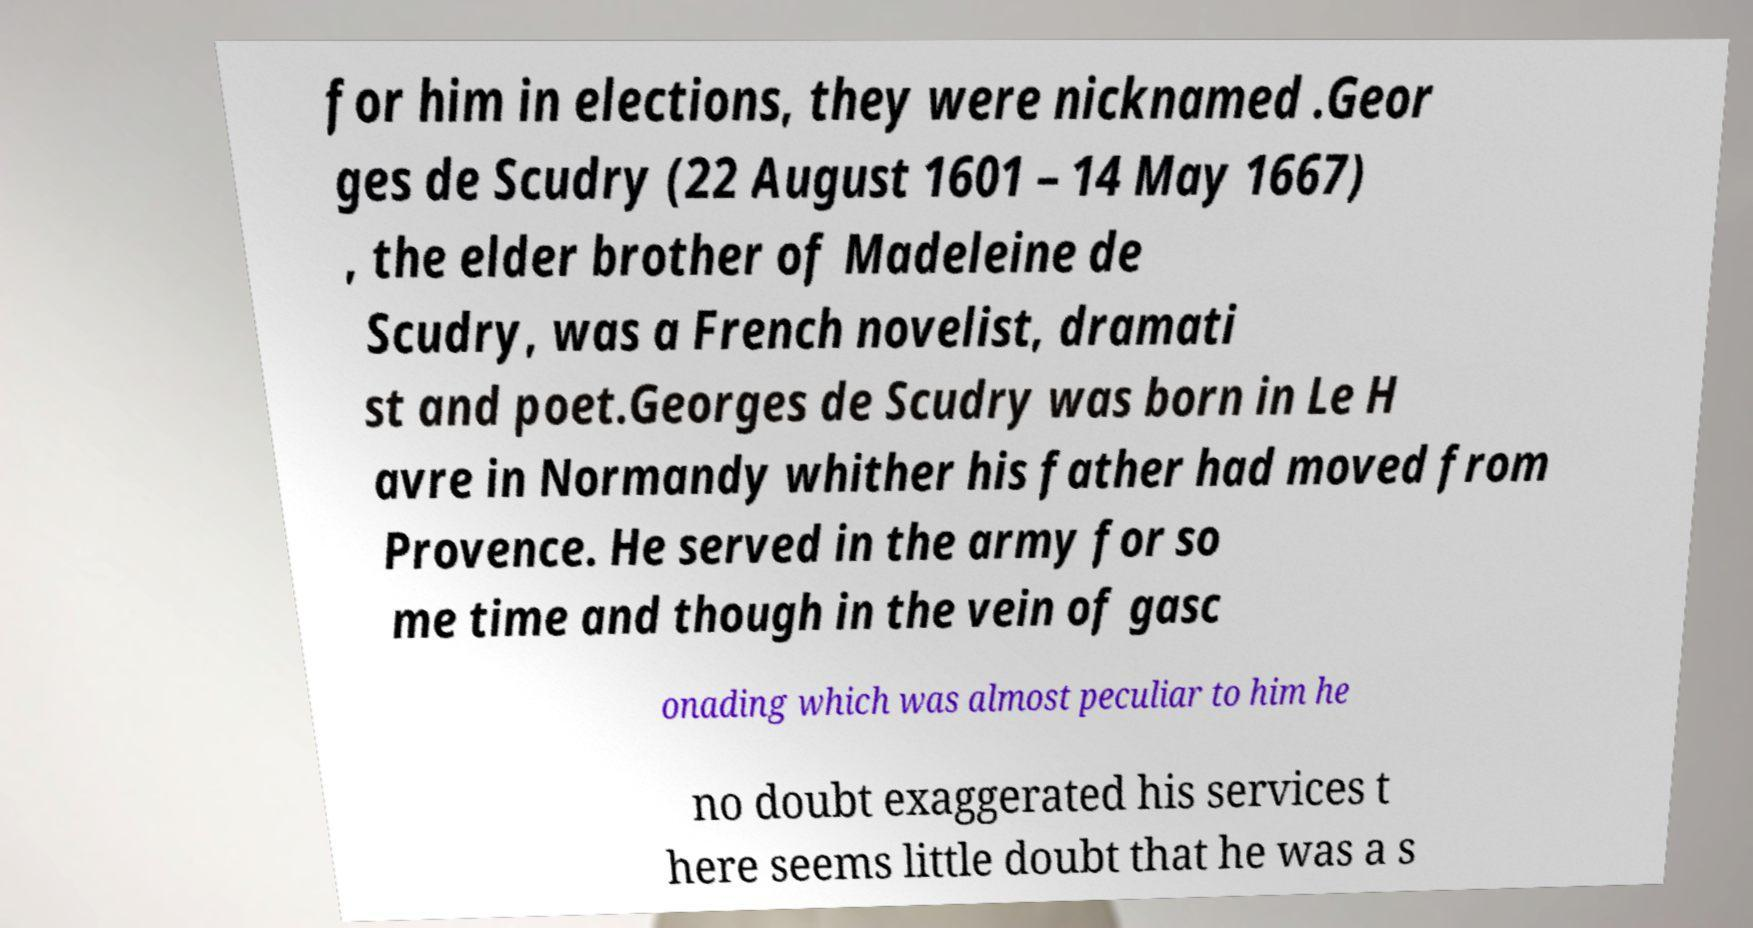Could you extract and type out the text from this image? for him in elections, they were nicknamed .Geor ges de Scudry (22 August 1601 – 14 May 1667) , the elder brother of Madeleine de Scudry, was a French novelist, dramati st and poet.Georges de Scudry was born in Le H avre in Normandy whither his father had moved from Provence. He served in the army for so me time and though in the vein of gasc onading which was almost peculiar to him he no doubt exaggerated his services t here seems little doubt that he was a s 